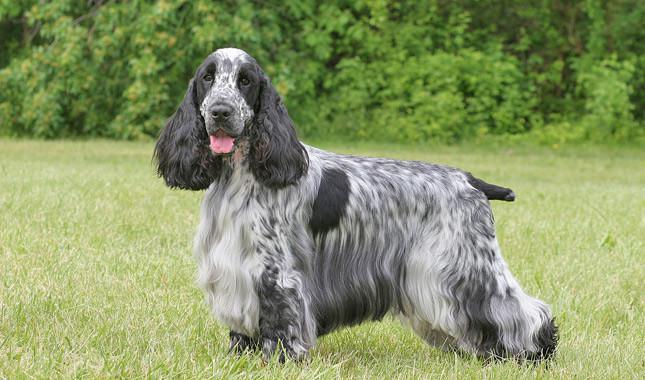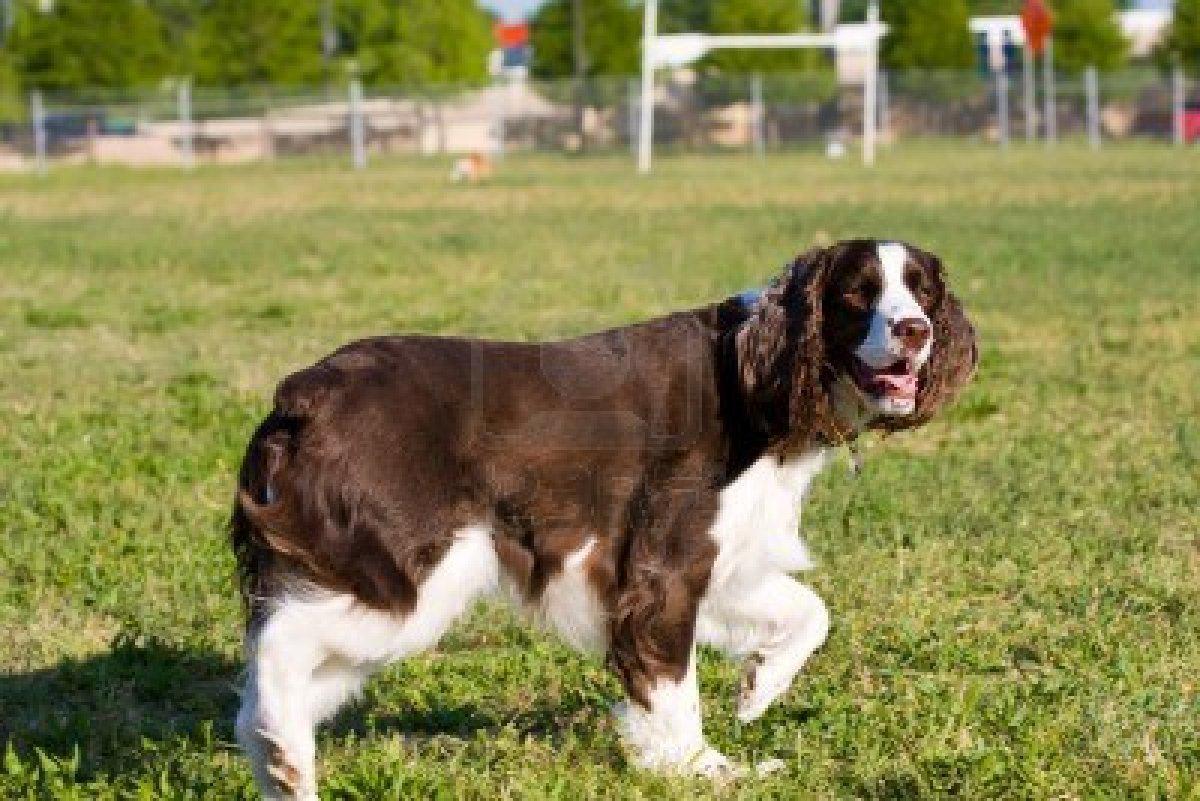The first image is the image on the left, the second image is the image on the right. For the images displayed, is the sentence "The dog in the image on the right is on a dirt pathway in the grass." factually correct? Answer yes or no. No. The first image is the image on the left, the second image is the image on the right. For the images shown, is this caption "The dog in the right image is walking on the grass in profile." true? Answer yes or no. Yes. 